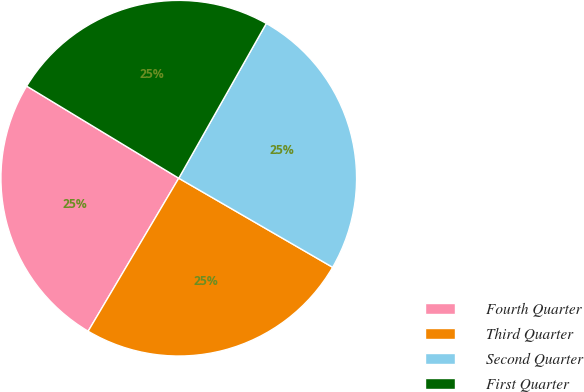Convert chart. <chart><loc_0><loc_0><loc_500><loc_500><pie_chart><fcel>Fourth Quarter<fcel>Third Quarter<fcel>Second Quarter<fcel>First Quarter<nl><fcel>25.16%<fcel>25.16%<fcel>25.16%<fcel>24.53%<nl></chart> 